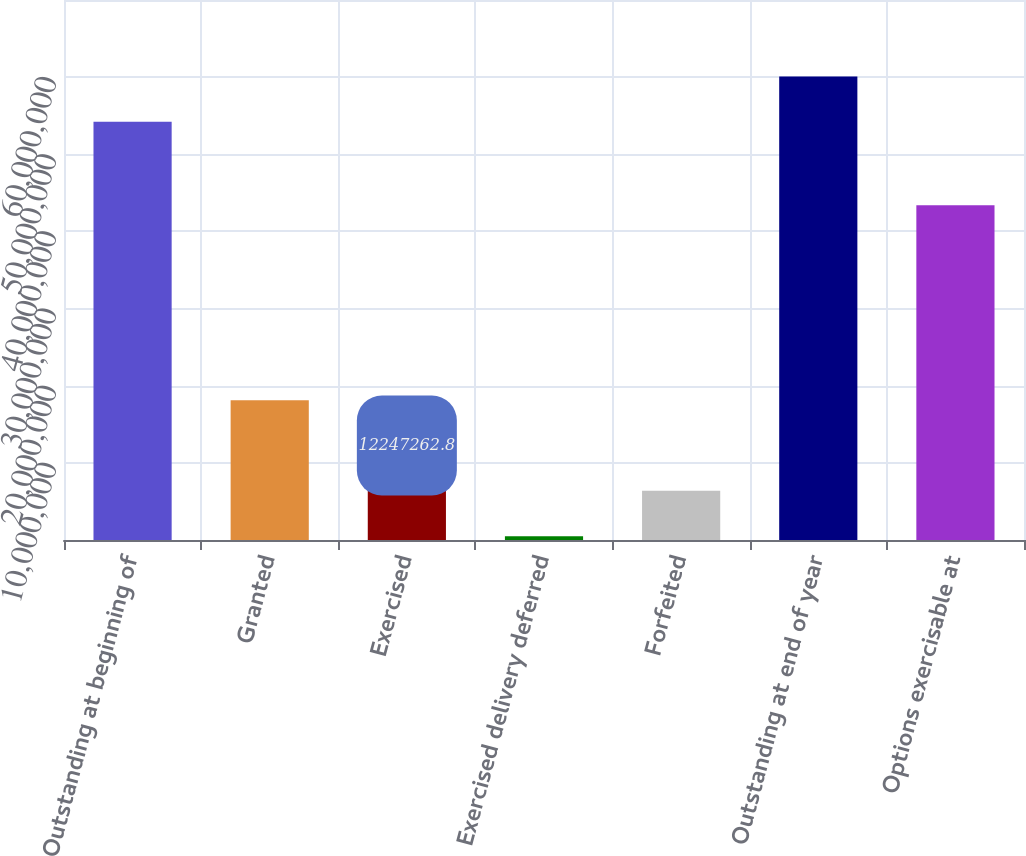Convert chart. <chart><loc_0><loc_0><loc_500><loc_500><bar_chart><fcel>Outstanding at beginning of<fcel>Granted<fcel>Exercised<fcel>Exercised delivery deferred<fcel>Forfeited<fcel>Outstanding at end of year<fcel>Options exercisable at<nl><fcel>5.4214e+07<fcel>1.8123e+07<fcel>1.22473e+07<fcel>495787<fcel>6.37152e+06<fcel>6.00898e+07<fcel>4.33976e+07<nl></chart> 